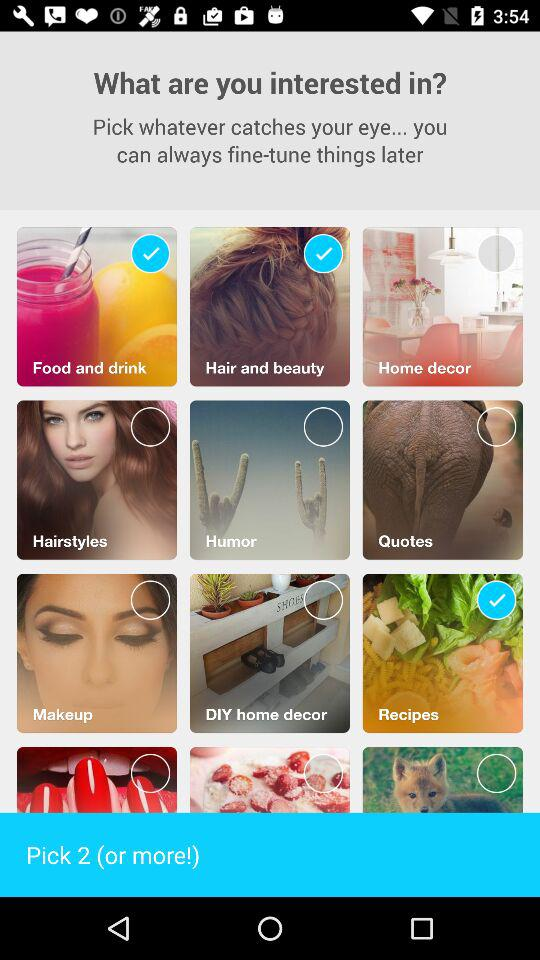How many topics can be picked? The number of topics that can be picked is 2 or more. 